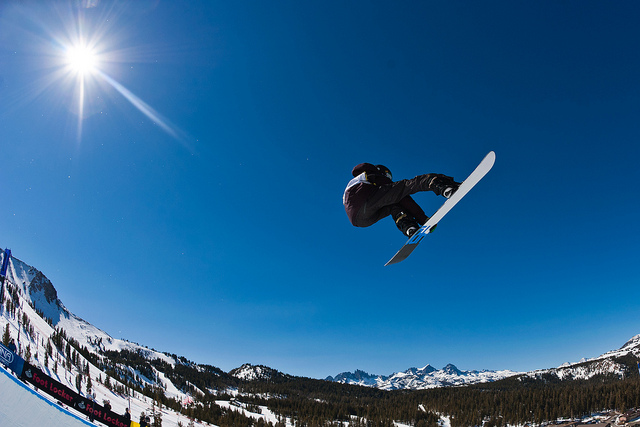<image>What does the bottom of the snowboard say? I am not sure what the bottom of the snowboard says. It could say 'burton', '492', 'volcom', or 'gbh'. What does the bottom of the snowboard say? I don't know what does the bottom of the snowboard say. It can be 'burton', '492', 'volcom', 'snow', 'nothing' or 'gbh'. 